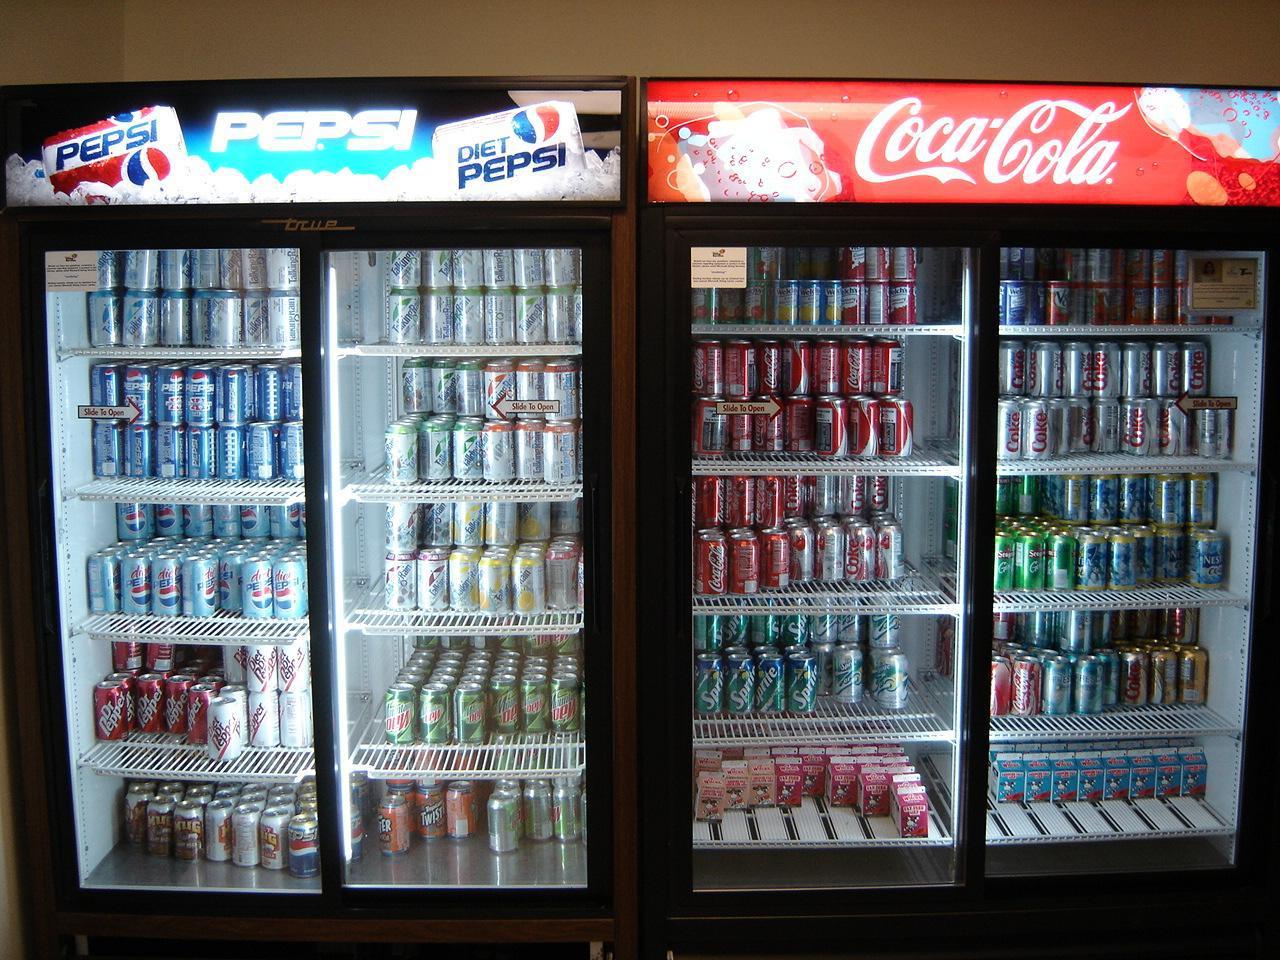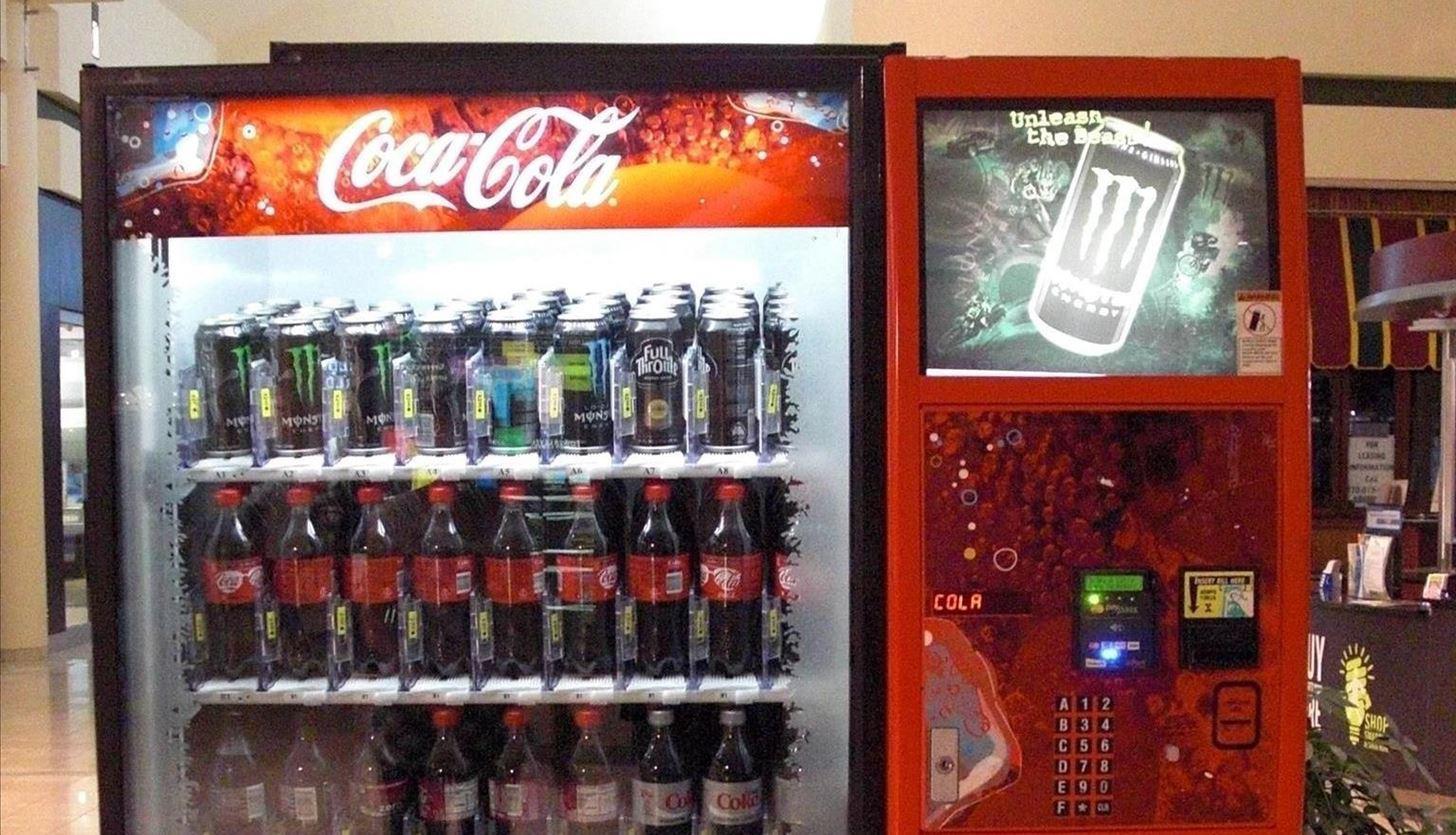The first image is the image on the left, the second image is the image on the right. Given the left and right images, does the statement "Left image shows a vending machine that does not dispense beverages." hold true? Answer yes or no. No. The first image is the image on the left, the second image is the image on the right. Assess this claim about the two images: "there are red vending machines". Correct or not? Answer yes or no. Yes. 